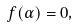<formula> <loc_0><loc_0><loc_500><loc_500>f ( \alpha ) = 0 ,</formula> 